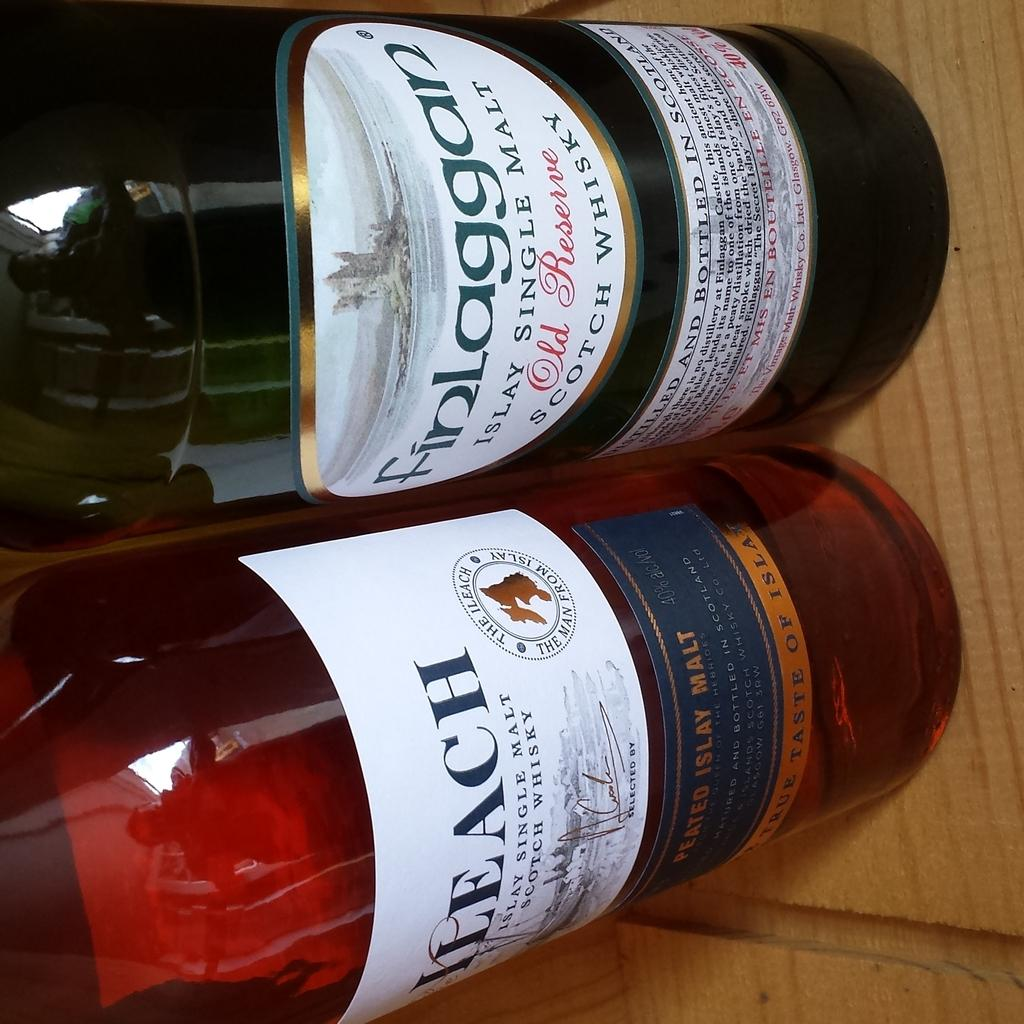<image>
Relay a brief, clear account of the picture shown. Two bottles of whisky including one named finlaggan. 